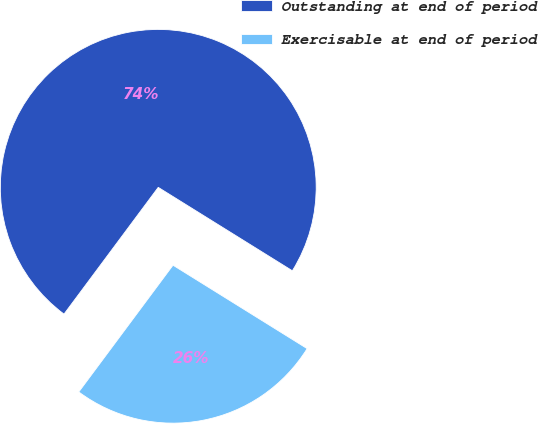Convert chart. <chart><loc_0><loc_0><loc_500><loc_500><pie_chart><fcel>Outstanding at end of period<fcel>Exercisable at end of period<nl><fcel>73.68%<fcel>26.32%<nl></chart> 